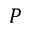Convert formula to latex. <formula><loc_0><loc_0><loc_500><loc_500>P</formula> 